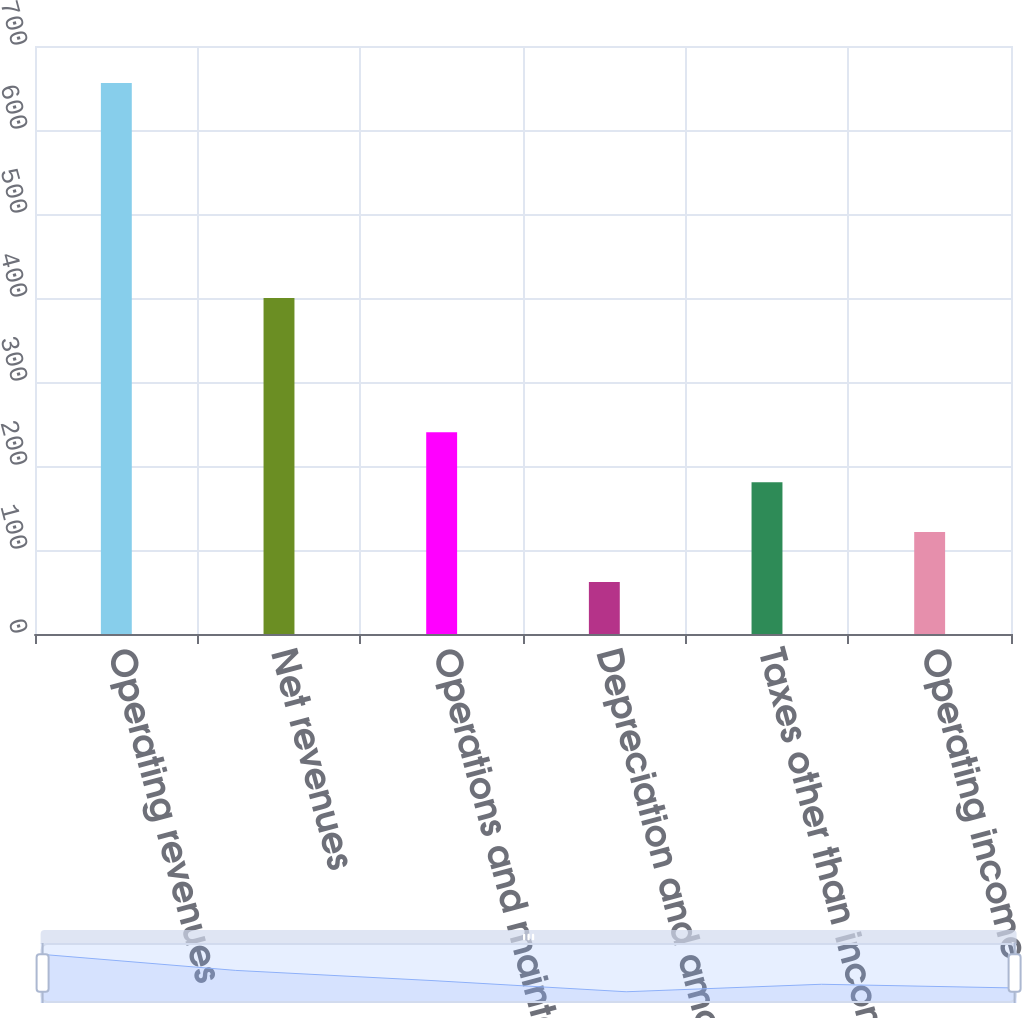Convert chart to OTSL. <chart><loc_0><loc_0><loc_500><loc_500><bar_chart><fcel>Operating revenues<fcel>Net revenues<fcel>Operations and maintenance<fcel>Depreciation and amortization<fcel>Taxes other than income taxes<fcel>Operating income<nl><fcel>656<fcel>400<fcel>240.2<fcel>62<fcel>180.8<fcel>121.4<nl></chart> 